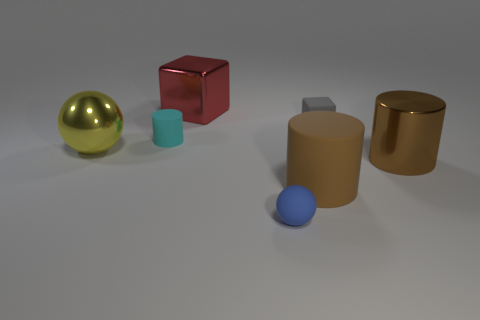How many objects are tiny matte objects that are in front of the large yellow shiny sphere or yellow rubber balls?
Provide a short and direct response. 1. There is a gray block behind the metal cylinder; how many blue rubber objects are right of it?
Your answer should be very brief. 0. Are there more metallic spheres that are on the left side of the cyan rubber cylinder than tiny purple matte spheres?
Your answer should be compact. Yes. What size is the rubber object that is in front of the tiny cyan cylinder and behind the small rubber ball?
Make the answer very short. Large. What is the shape of the large metallic object that is both right of the large yellow metal thing and left of the blue matte sphere?
Provide a succinct answer. Cube. There is a small object that is on the left side of the matte object that is in front of the large matte thing; are there any tiny gray objects right of it?
Your answer should be very brief. Yes. How many things are either small objects behind the blue ball or cylinders that are in front of the cyan rubber cylinder?
Provide a succinct answer. 4. Is the large brown cylinder left of the big brown metallic cylinder made of the same material as the small blue object?
Provide a succinct answer. Yes. There is a large object that is both to the left of the blue thing and right of the yellow metal sphere; what is its material?
Your answer should be very brief. Metal. The rubber cylinder that is in front of the metal thing that is in front of the big yellow metallic object is what color?
Make the answer very short. Brown. 